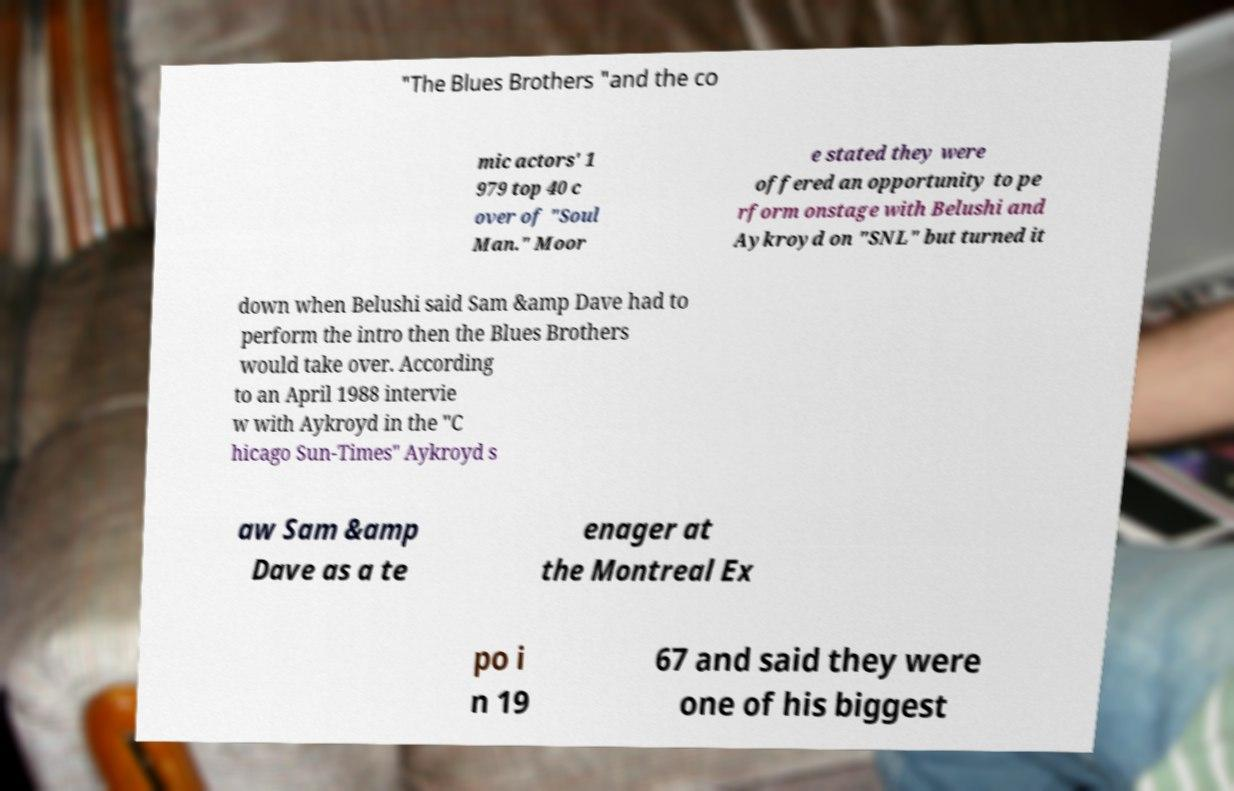Please read and relay the text visible in this image. What does it say? "The Blues Brothers "and the co mic actors' 1 979 top 40 c over of "Soul Man." Moor e stated they were offered an opportunity to pe rform onstage with Belushi and Aykroyd on "SNL" but turned it down when Belushi said Sam &amp Dave had to perform the intro then the Blues Brothers would take over. According to an April 1988 intervie w with Aykroyd in the "C hicago Sun-Times" Aykroyd s aw Sam &amp Dave as a te enager at the Montreal Ex po i n 19 67 and said they were one of his biggest 